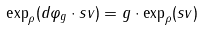<formula> <loc_0><loc_0><loc_500><loc_500>\exp _ { \rho } ( d \varphi _ { g } \cdot s v ) = g \cdot \exp _ { \rho } ( s v )</formula> 